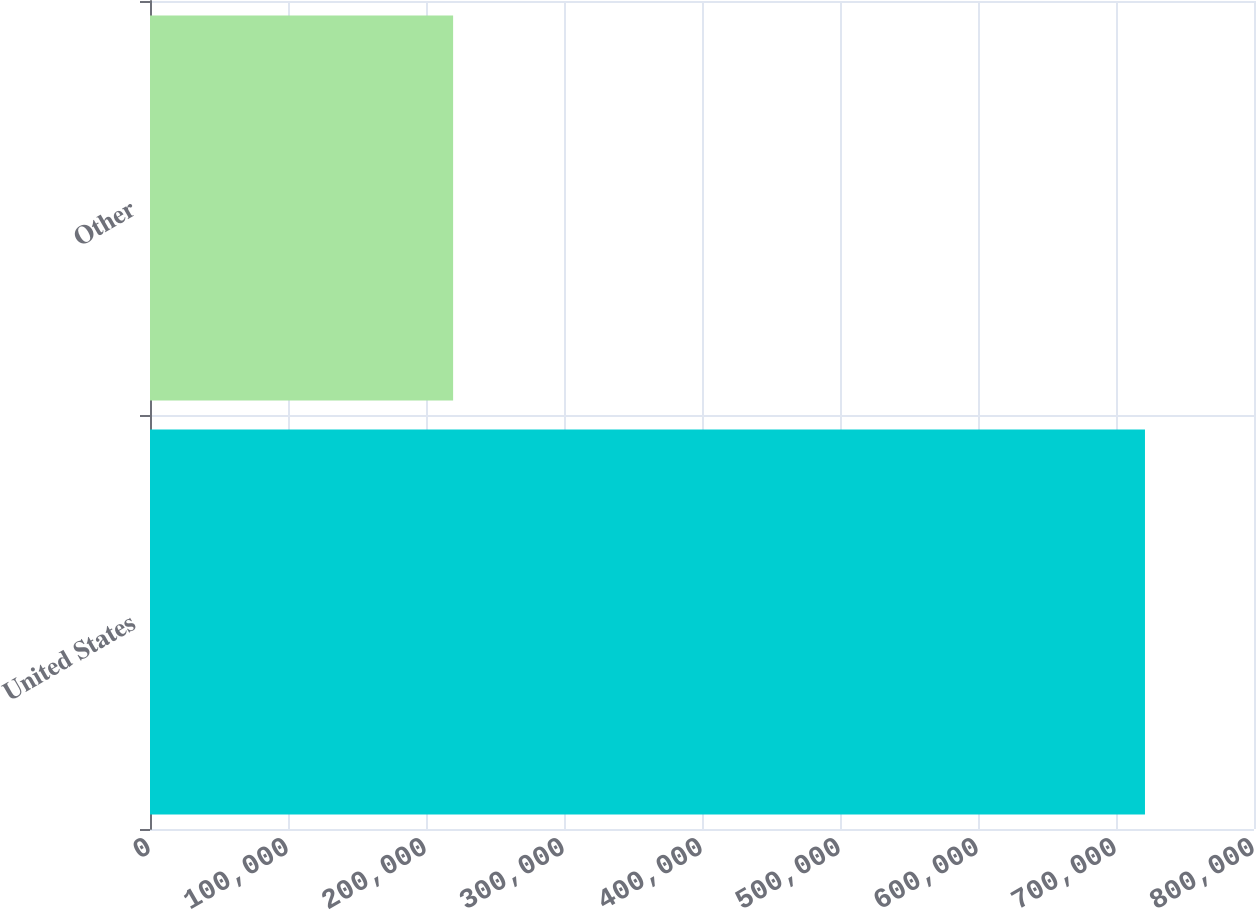Convert chart to OTSL. <chart><loc_0><loc_0><loc_500><loc_500><bar_chart><fcel>United States<fcel>Other<nl><fcel>721000<fcel>219652<nl></chart> 